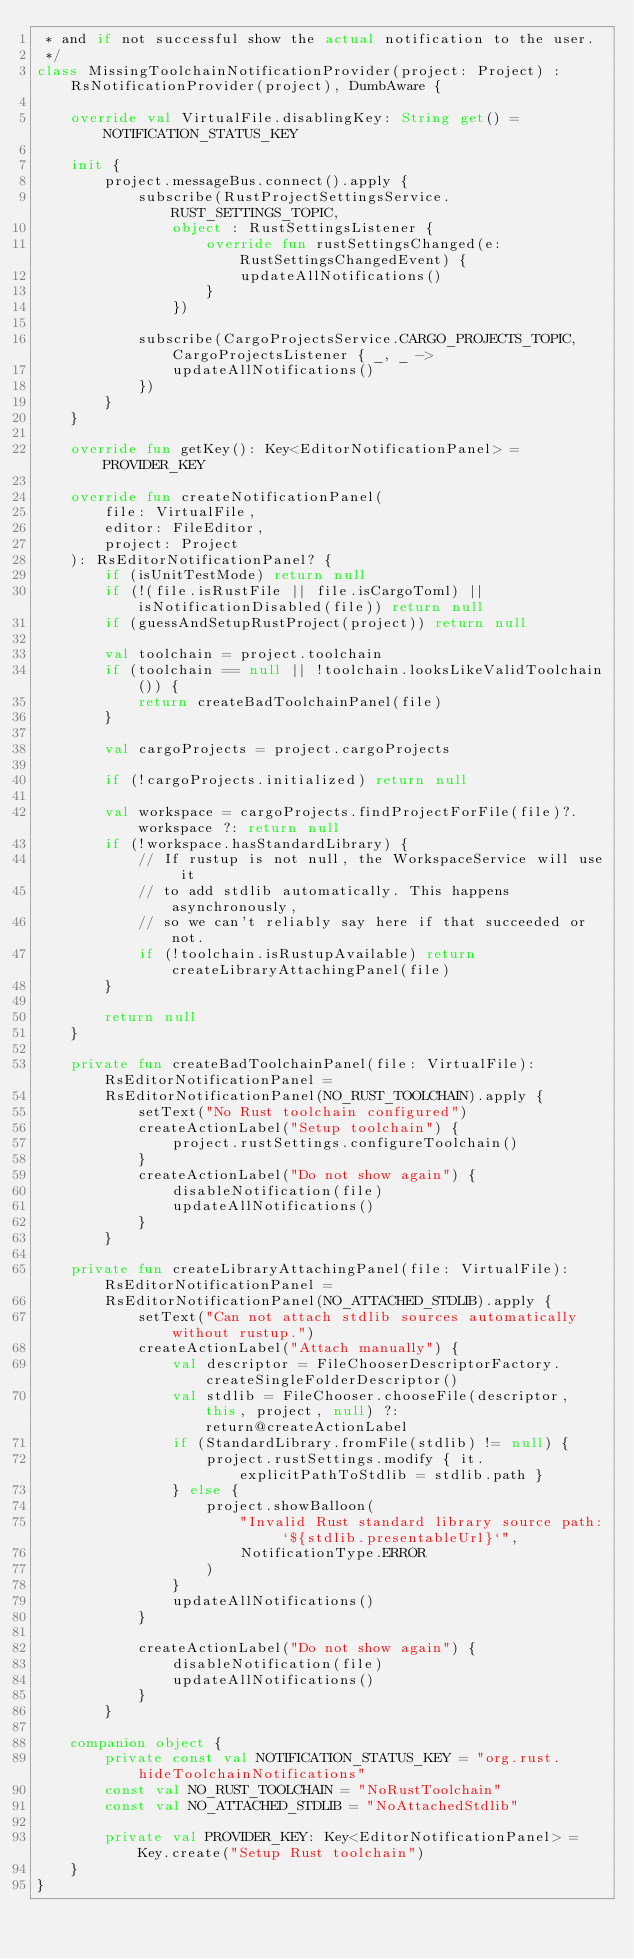<code> <loc_0><loc_0><loc_500><loc_500><_Kotlin_> * and if not successful show the actual notification to the user.
 */
class MissingToolchainNotificationProvider(project: Project) : RsNotificationProvider(project), DumbAware {

    override val VirtualFile.disablingKey: String get() = NOTIFICATION_STATUS_KEY

    init {
        project.messageBus.connect().apply {
            subscribe(RustProjectSettingsService.RUST_SETTINGS_TOPIC,
                object : RustSettingsListener {
                    override fun rustSettingsChanged(e: RustSettingsChangedEvent) {
                        updateAllNotifications()
                    }
                })

            subscribe(CargoProjectsService.CARGO_PROJECTS_TOPIC, CargoProjectsListener { _, _ ->
                updateAllNotifications()
            })
        }
    }

    override fun getKey(): Key<EditorNotificationPanel> = PROVIDER_KEY

    override fun createNotificationPanel(
        file: VirtualFile,
        editor: FileEditor,
        project: Project
    ): RsEditorNotificationPanel? {
        if (isUnitTestMode) return null
        if (!(file.isRustFile || file.isCargoToml) || isNotificationDisabled(file)) return null
        if (guessAndSetupRustProject(project)) return null

        val toolchain = project.toolchain
        if (toolchain == null || !toolchain.looksLikeValidToolchain()) {
            return createBadToolchainPanel(file)
        }

        val cargoProjects = project.cargoProjects

        if (!cargoProjects.initialized) return null

        val workspace = cargoProjects.findProjectForFile(file)?.workspace ?: return null
        if (!workspace.hasStandardLibrary) {
            // If rustup is not null, the WorkspaceService will use it
            // to add stdlib automatically. This happens asynchronously,
            // so we can't reliably say here if that succeeded or not.
            if (!toolchain.isRustupAvailable) return createLibraryAttachingPanel(file)
        }

        return null
    }

    private fun createBadToolchainPanel(file: VirtualFile): RsEditorNotificationPanel =
        RsEditorNotificationPanel(NO_RUST_TOOLCHAIN).apply {
            setText("No Rust toolchain configured")
            createActionLabel("Setup toolchain") {
                project.rustSettings.configureToolchain()
            }
            createActionLabel("Do not show again") {
                disableNotification(file)
                updateAllNotifications()
            }
        }

    private fun createLibraryAttachingPanel(file: VirtualFile): RsEditorNotificationPanel =
        RsEditorNotificationPanel(NO_ATTACHED_STDLIB).apply {
            setText("Can not attach stdlib sources automatically without rustup.")
            createActionLabel("Attach manually") {
                val descriptor = FileChooserDescriptorFactory.createSingleFolderDescriptor()
                val stdlib = FileChooser.chooseFile(descriptor, this, project, null) ?: return@createActionLabel
                if (StandardLibrary.fromFile(stdlib) != null) {
                    project.rustSettings.modify { it.explicitPathToStdlib = stdlib.path }
                } else {
                    project.showBalloon(
                        "Invalid Rust standard library source path: `${stdlib.presentableUrl}`",
                        NotificationType.ERROR
                    )
                }
                updateAllNotifications()
            }

            createActionLabel("Do not show again") {
                disableNotification(file)
                updateAllNotifications()
            }
        }

    companion object {
        private const val NOTIFICATION_STATUS_KEY = "org.rust.hideToolchainNotifications"
        const val NO_RUST_TOOLCHAIN = "NoRustToolchain"
        const val NO_ATTACHED_STDLIB = "NoAttachedStdlib"

        private val PROVIDER_KEY: Key<EditorNotificationPanel> = Key.create("Setup Rust toolchain")
    }
}
</code> 